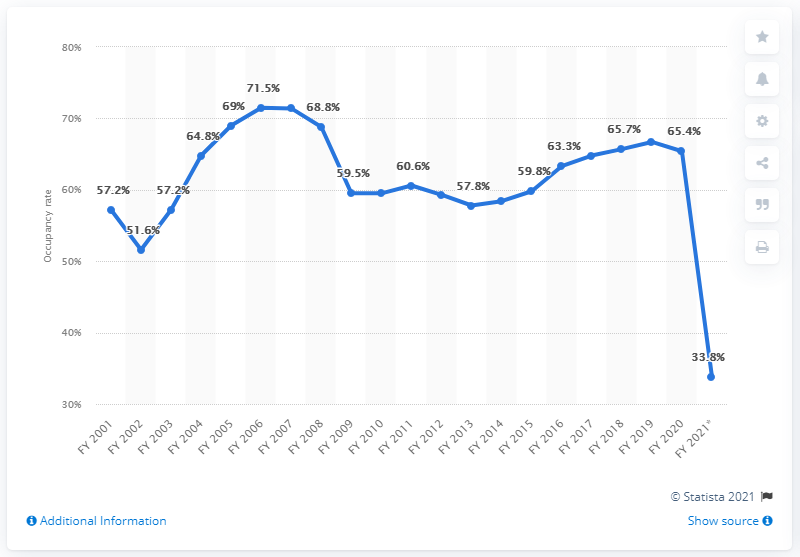List a handful of essential elements in this visual. During the fiscal year 2021, the occupancy rate of hotels in India was 33.8%. The occupancy rate of hotels in India has been consistently high in recent years, with a recorded rate of 59.8% in the most recent year. 